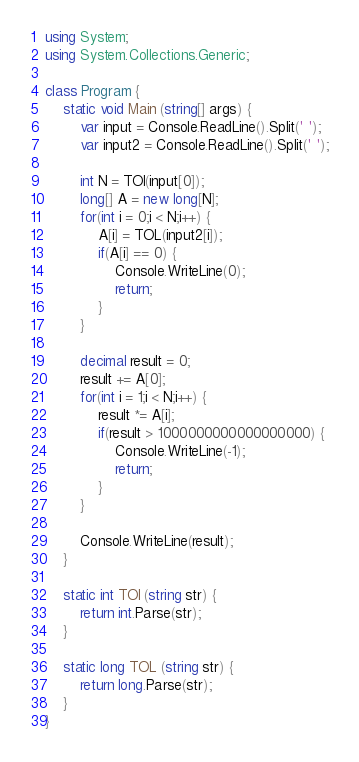Convert code to text. <code><loc_0><loc_0><loc_500><loc_500><_C#_>using System;
using System.Collections.Generic;

class Program {
    static void Main (string[] args) {
        var input = Console.ReadLine().Split(' ');
        var input2 = Console.ReadLine().Split(' ');

        int N = TOI(input[0]);
        long[] A = new long[N];
        for(int i = 0;i < N;i++) {
            A[i] = TOL(input2[i]);
            if(A[i] == 0) {
                Console.WriteLine(0);
                return;
            }
        }

        decimal result = 0;
        result += A[0];
        for(int i = 1;i < N;i++) {
            result *= A[i];
            if(result > 1000000000000000000) {
                Console.WriteLine(-1);
                return;
            }
        }

        Console.WriteLine(result);
    }

    static int TOI (string str) {
        return int.Parse(str);
    }

    static long TOL (string str) {
        return long.Parse(str);
    }
}
</code> 